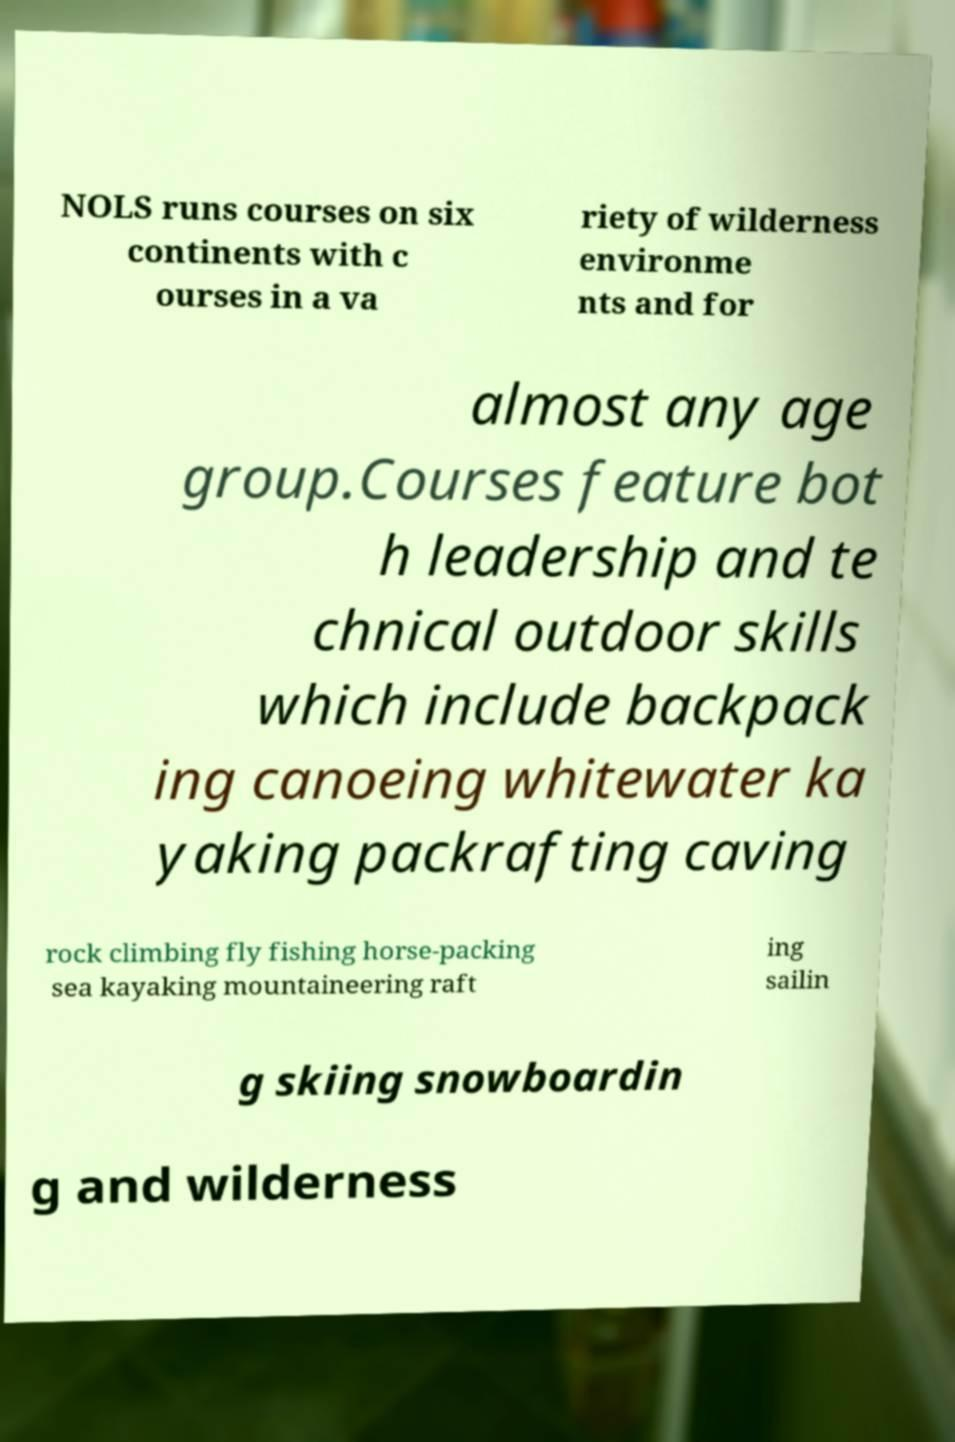Can you read and provide the text displayed in the image?This photo seems to have some interesting text. Can you extract and type it out for me? NOLS runs courses on six continents with c ourses in a va riety of wilderness environme nts and for almost any age group.Courses feature bot h leadership and te chnical outdoor skills which include backpack ing canoeing whitewater ka yaking packrafting caving rock climbing fly fishing horse-packing sea kayaking mountaineering raft ing sailin g skiing snowboardin g and wilderness 